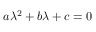<formula> <loc_0><loc_0><loc_500><loc_500>a \lambda ^ { 2 } + b \lambda + c = 0</formula> 